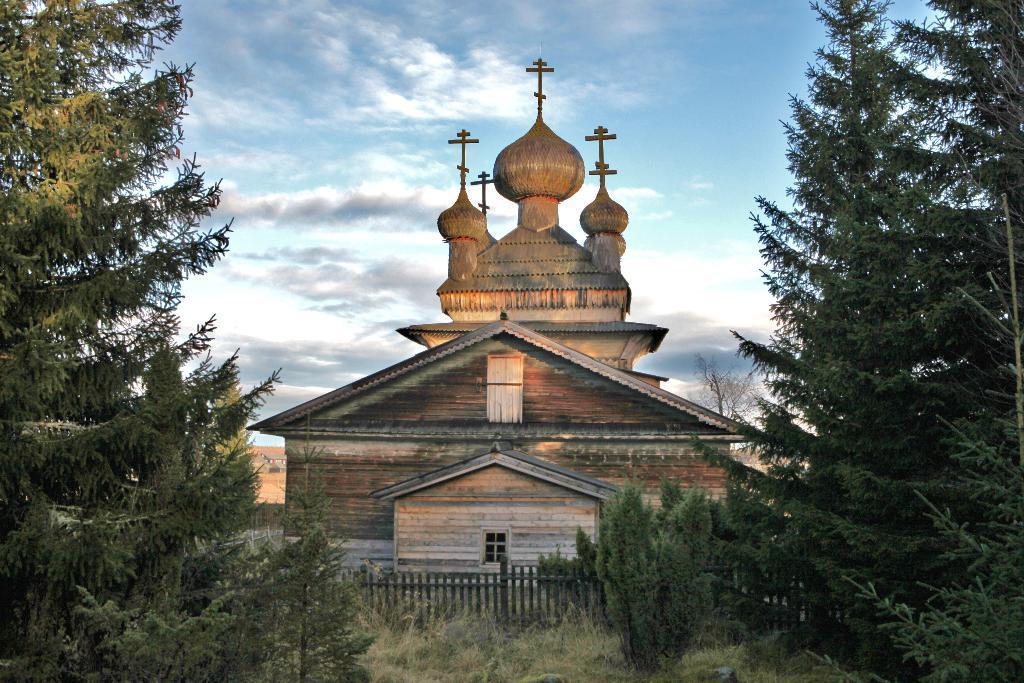How would you summarize this image in a sentence or two? This is an outside view. In the middle of the image there is a building. At the bottom, I can see the grass on the ground and there is a fencing. On the right and left side of the image I can see the trees. At the top of the image I can see the sky and clouds. 